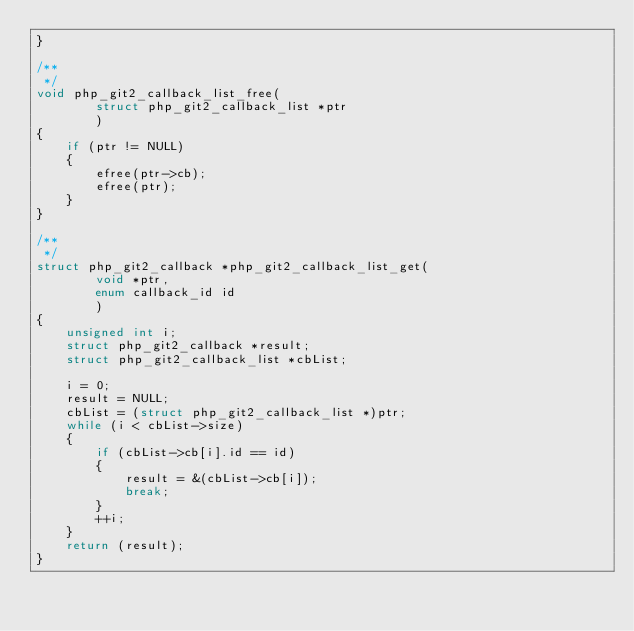Convert code to text. <code><loc_0><loc_0><loc_500><loc_500><_C_>}

/**
 */
void php_git2_callback_list_free(
        struct php_git2_callback_list *ptr
        )
{
    if (ptr != NULL)
    {
        efree(ptr->cb);
        efree(ptr);
    }
}

/**
 */
struct php_git2_callback *php_git2_callback_list_get(
        void *ptr,
        enum callback_id id
        )
{
    unsigned int i;
    struct php_git2_callback *result;
    struct php_git2_callback_list *cbList;

    i = 0;
    result = NULL;
    cbList = (struct php_git2_callback_list *)ptr;
    while (i < cbList->size)
    {
        if (cbList->cb[i].id == id)
        {
            result = &(cbList->cb[i]);
            break;
        }
        ++i;
    }
    return (result);
}

</code> 